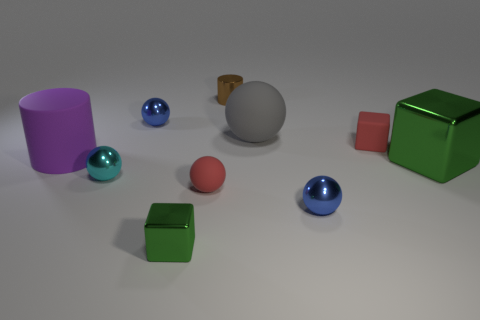There is a blue metal ball behind the purple rubber cylinder; is it the same size as the big shiny thing?
Make the answer very short. No. The small brown shiny thing has what shape?
Make the answer very short. Cylinder. What is the size of the cyan thing that is made of the same material as the small brown object?
Provide a short and direct response. Small. Is the number of cyan metallic balls that are behind the cyan shiny object greater than the number of tiny red matte objects?
Your answer should be very brief. No. There is a brown metallic thing; is its shape the same as the small red rubber object that is to the left of the tiny rubber block?
Offer a very short reply. No. How many tiny things are either rubber things or green things?
Make the answer very short. 3. What size is the matte sphere that is the same color as the matte block?
Make the answer very short. Small. The cylinder that is in front of the tiny red object behind the large shiny cube is what color?
Give a very brief answer. Purple. Does the purple object have the same material as the tiny sphere behind the tiny cyan metal thing?
Your answer should be compact. No. There is a big object behind the big matte cylinder; what is it made of?
Give a very brief answer. Rubber. 